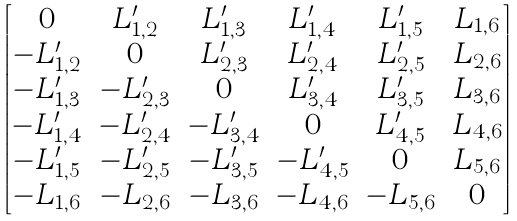<formula> <loc_0><loc_0><loc_500><loc_500>\begin{bmatrix} 0 & L ^ { \prime } _ { 1 , 2 } & L ^ { \prime } _ { 1 , 3 } & L ^ { \prime } _ { 1 , 4 } & L ^ { \prime } _ { 1 , 5 } & L _ { 1 , 6 } \\ - L ^ { \prime } _ { 1 , 2 } & 0 & L ^ { \prime } _ { 2 , 3 } & L ^ { \prime } _ { 2 , 4 } & L ^ { \prime } _ { 2 , 5 } & L _ { 2 , 6 } \\ - L ^ { \prime } _ { 1 , 3 } & - L ^ { \prime } _ { 2 , 3 } & 0 & L ^ { \prime } _ { 3 , 4 } & L ^ { \prime } _ { 3 , 5 } & L _ { 3 , 6 } \\ - L ^ { \prime } _ { 1 , 4 } & - L ^ { \prime } _ { 2 , 4 } & - L ^ { \prime } _ { 3 , 4 } & 0 & L ^ { \prime } _ { 4 , 5 } & L _ { 4 , 6 } \\ - L ^ { \prime } _ { 1 , 5 } & - L ^ { \prime } _ { 2 , 5 } & - L ^ { \prime } _ { 3 , 5 } & - L ^ { \prime } _ { 4 , 5 } & 0 & L _ { 5 , 6 } \\ - L _ { 1 , 6 } & - L _ { 2 , 6 } & - L _ { 3 , 6 } & - L _ { 4 , 6 } & - L _ { 5 , 6 } & 0 \end{bmatrix}</formula> 